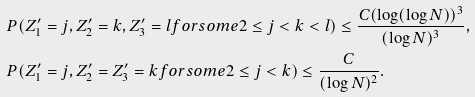<formula> <loc_0><loc_0><loc_500><loc_500>& P ( Z ^ { \prime } _ { 1 } = j , Z ^ { \prime } _ { 2 } = k , Z ^ { \prime } _ { 3 } = l f o r s o m e 2 \leq j < k < l ) \leq \frac { C ( \log ( \log N ) ) ^ { 3 } } { ( \log N ) ^ { 3 } } , \\ & P ( Z ^ { \prime } _ { 1 } = j , Z ^ { \prime } _ { 2 } = Z ^ { \prime } _ { 3 } = k f o r s o m e 2 \leq j < k ) \leq \frac { C } { ( \log N ) ^ { 2 } } .</formula> 